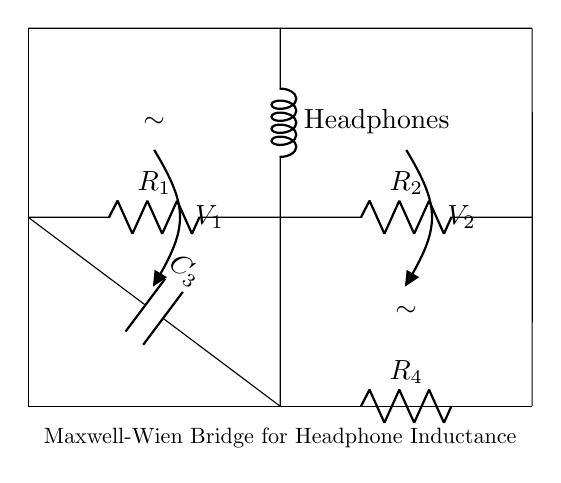What components are in the Maxwell-Wien bridge? The components include resistors R1 and R2, capacitor C3, inductor Lx representing the studio headphones, and resistor R4. All are essential for the bridge's balancing and measurement capabilities.
Answer: R1, R2, C3, Lx, R4 What does Lx represent in this circuit? Lx represents the inductance of the studio headphones, which is the primary measurement we aim to determine using the bridge configuration.
Answer: Inductance of studio headphones What is the role of the capacitor C3? The role of C3 is to help balance the bridge by providing a reactive component that compensates for the inductance in the circuit; it creates a path for AC signals while influencing the overall impedance.
Answer: Balancing the bridge How do you measure the inductance of the headphones? The inductance is measured by adjusting the known resistances R1, R2, and R4 until the bridge is balanced, indicated by equal voltages V1 and V2 across the points marked. The balance condition allows the inductance to be calculated using the known values.
Answer: By balancing resistances What happens when the bridge is balanced? When the bridge is balanced, the voltage across the measuring points (V1 and V2) is equal, indicating that the ratio of resistances and the reactance of the capacitor is equal to the inductance of the headphones, allowing us to calculate the inductance accurately.
Answer: V1 equals V2 What is the significance of the voltage sources marked V1 and V2? The voltage sources V1 and V2 indicate the measured voltages across the respective branches of the circuit. They help determine the balance of the bridge, crucial for accurately assessing inductance.
Answer: Measured voltages for balance 